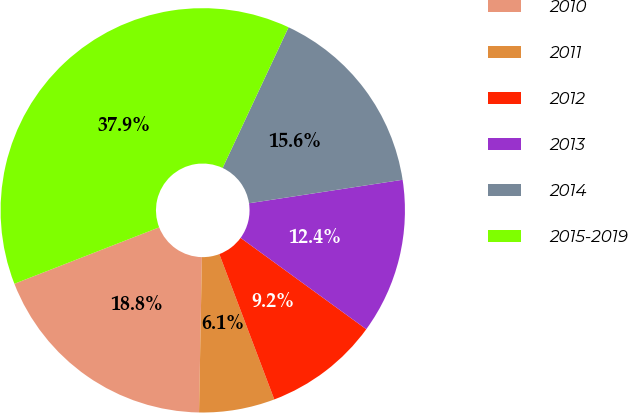Convert chart to OTSL. <chart><loc_0><loc_0><loc_500><loc_500><pie_chart><fcel>2010<fcel>2011<fcel>2012<fcel>2013<fcel>2014<fcel>2015-2019<nl><fcel>18.79%<fcel>6.05%<fcel>9.24%<fcel>12.42%<fcel>15.61%<fcel>37.89%<nl></chart> 